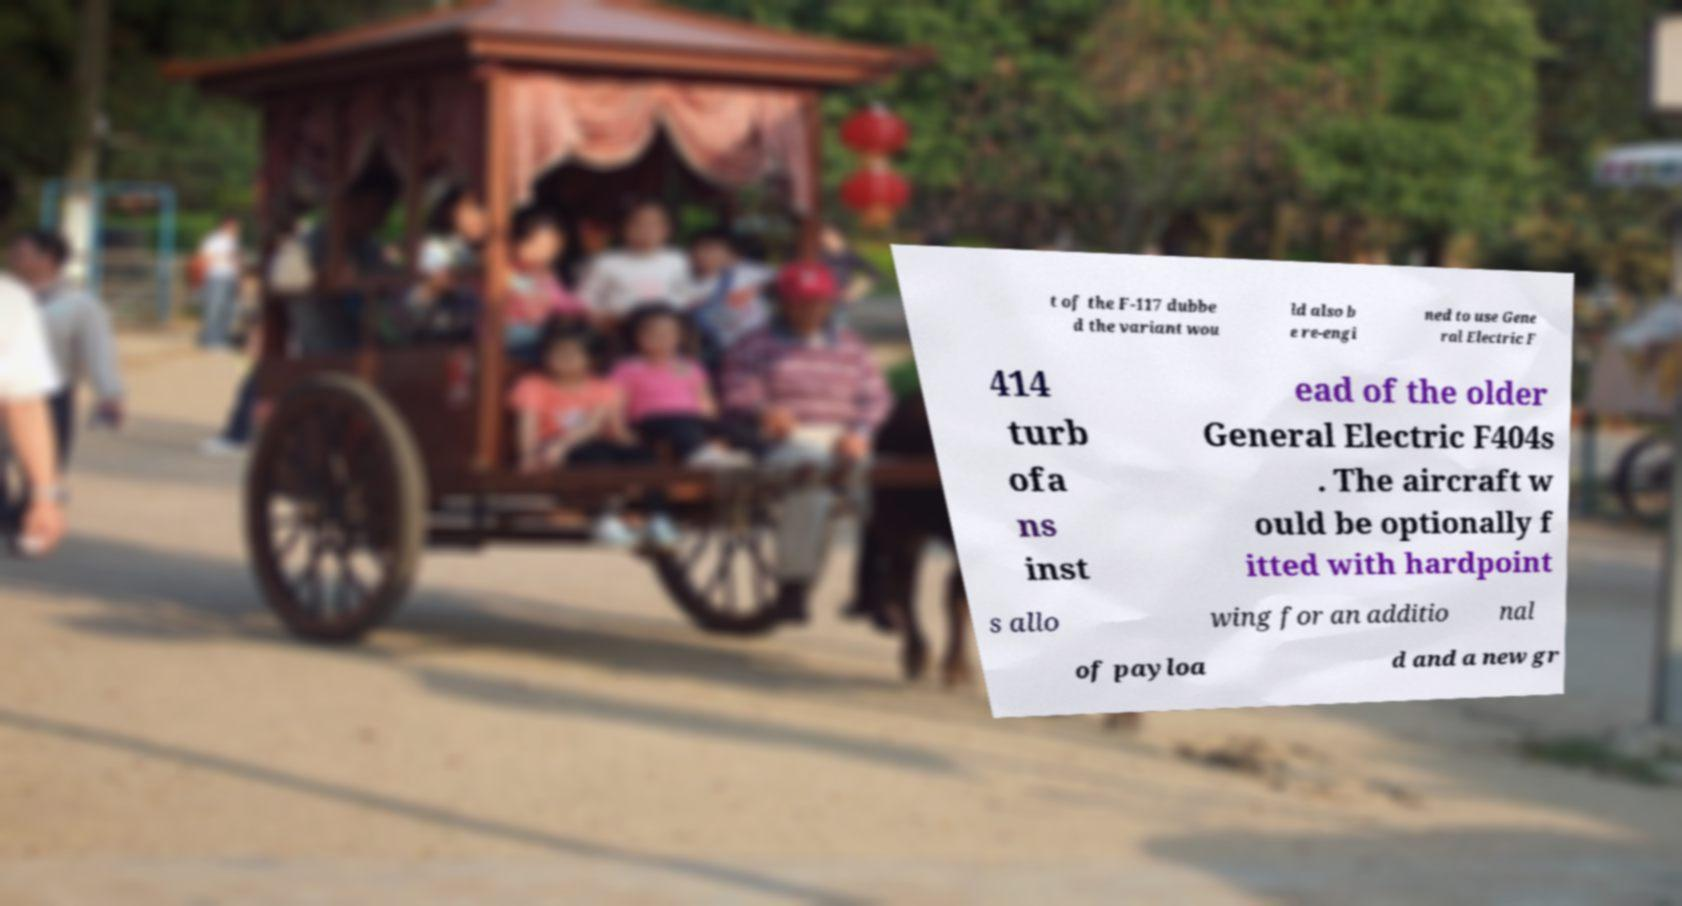Could you assist in decoding the text presented in this image and type it out clearly? t of the F-117 dubbe d the variant wou ld also b e re-engi ned to use Gene ral Electric F 414 turb ofa ns inst ead of the older General Electric F404s . The aircraft w ould be optionally f itted with hardpoint s allo wing for an additio nal of payloa d and a new gr 